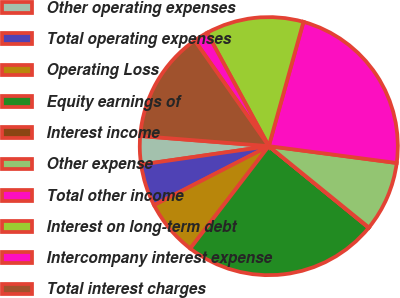Convert chart to OTSL. <chart><loc_0><loc_0><loc_500><loc_500><pie_chart><fcel>Other operating expenses<fcel>Total operating expenses<fcel>Operating Loss<fcel>Equity earnings of<fcel>Interest income<fcel>Other expense<fcel>Total other income<fcel>Interest on long-term debt<fcel>Intercompany interest expense<fcel>Total interest charges<nl><fcel>3.53%<fcel>5.28%<fcel>7.03%<fcel>24.51%<fcel>0.04%<fcel>8.78%<fcel>22.76%<fcel>12.27%<fcel>1.79%<fcel>14.02%<nl></chart> 